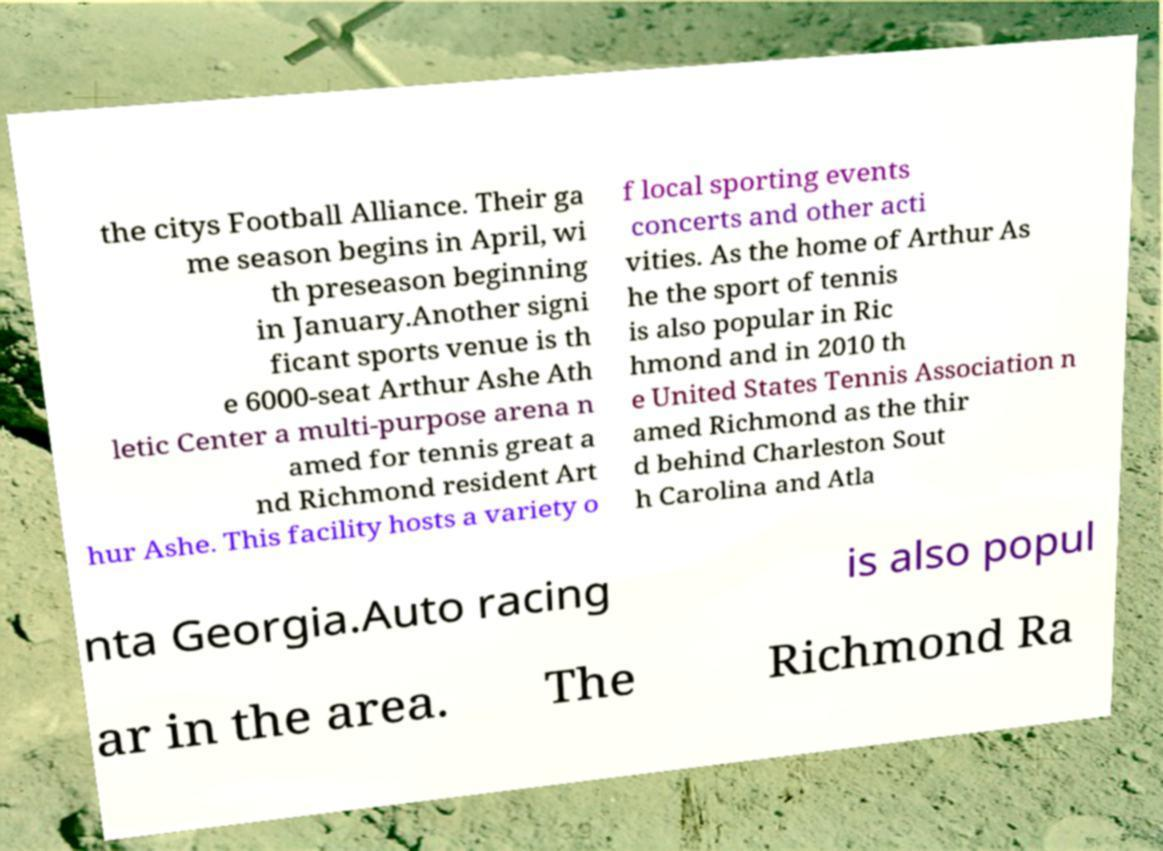I need the written content from this picture converted into text. Can you do that? the citys Football Alliance. Their ga me season begins in April, wi th preseason beginning in January.Another signi ficant sports venue is th e 6000-seat Arthur Ashe Ath letic Center a multi-purpose arena n amed for tennis great a nd Richmond resident Art hur Ashe. This facility hosts a variety o f local sporting events concerts and other acti vities. As the home of Arthur As he the sport of tennis is also popular in Ric hmond and in 2010 th e United States Tennis Association n amed Richmond as the thir d behind Charleston Sout h Carolina and Atla nta Georgia.Auto racing is also popul ar in the area. The Richmond Ra 